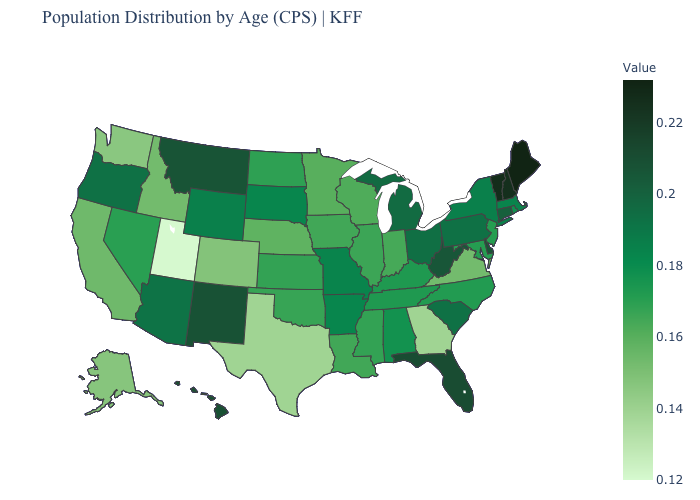Which states have the lowest value in the USA?
Short answer required. Utah. Which states have the lowest value in the MidWest?
Quick response, please. Nebraska. Does Utah have the lowest value in the West?
Short answer required. Yes. Which states have the lowest value in the Northeast?
Concise answer only. New Jersey. 